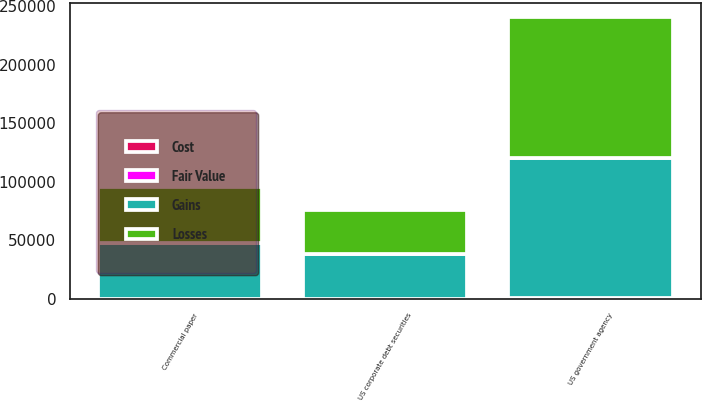Convert chart. <chart><loc_0><loc_0><loc_500><loc_500><stacked_bar_chart><ecel><fcel>Commercial paper<fcel>US government agency<fcel>US corporate debt securities<nl><fcel>Losses<fcel>47669<fcel>119961<fcel>37998<nl><fcel>Cost<fcel>27<fcel>305<fcel>106<nl><fcel>Fair Value<fcel>9<fcel>423<fcel>1<nl><fcel>Gains<fcel>47687<fcel>119843<fcel>38103<nl></chart> 